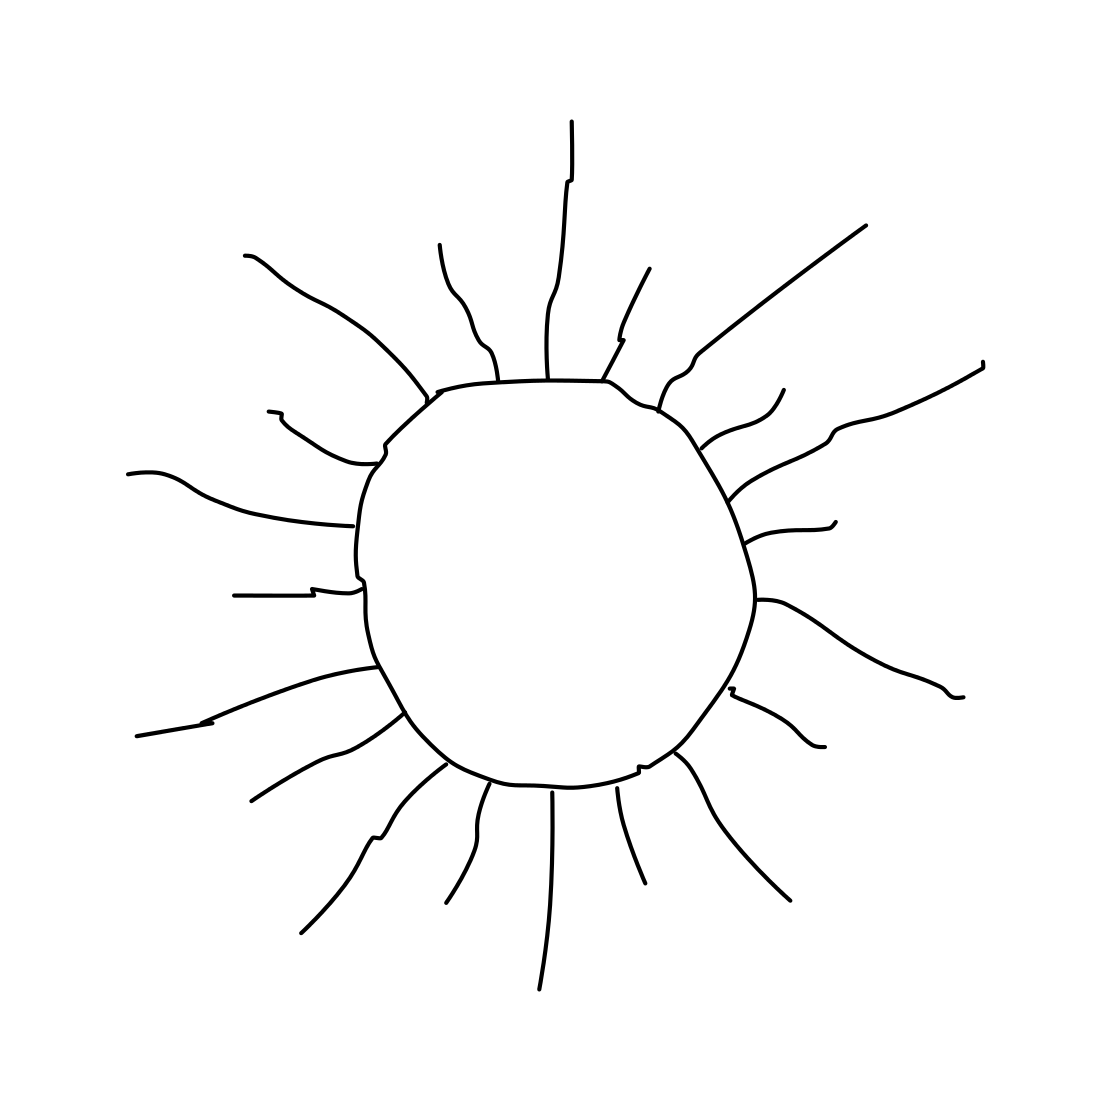In the scene, is a sun in it? Yes 